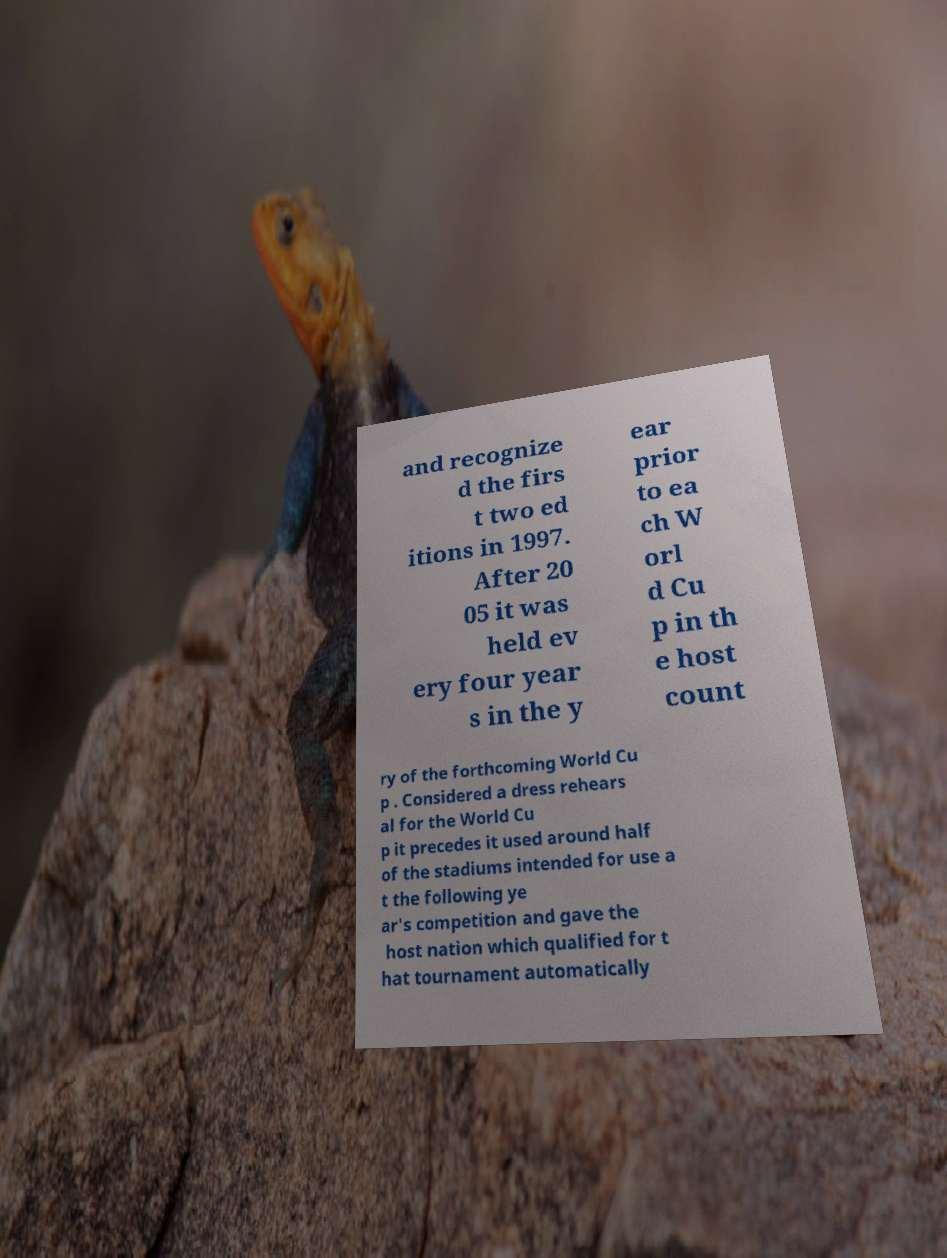Can you accurately transcribe the text from the provided image for me? and recognize d the firs t two ed itions in 1997. After 20 05 it was held ev ery four year s in the y ear prior to ea ch W orl d Cu p in th e host count ry of the forthcoming World Cu p . Considered a dress rehears al for the World Cu p it precedes it used around half of the stadiums intended for use a t the following ye ar's competition and gave the host nation which qualified for t hat tournament automatically 